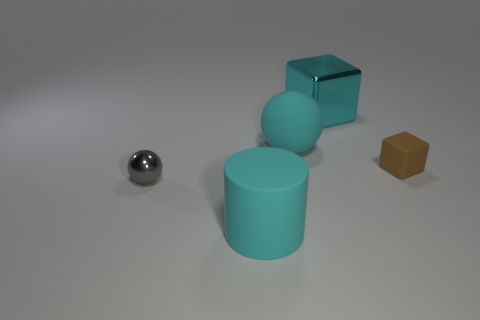How would the image change if the lighting source was moved to directly above the objects? With the lighting source directly above, the shadows of the objects would appear shorter and more symmetrical. The highlight reflections on the spherical and metallic surfaces would shift to the top, creating more pronounced contrasts and a different visual aesthetic. 